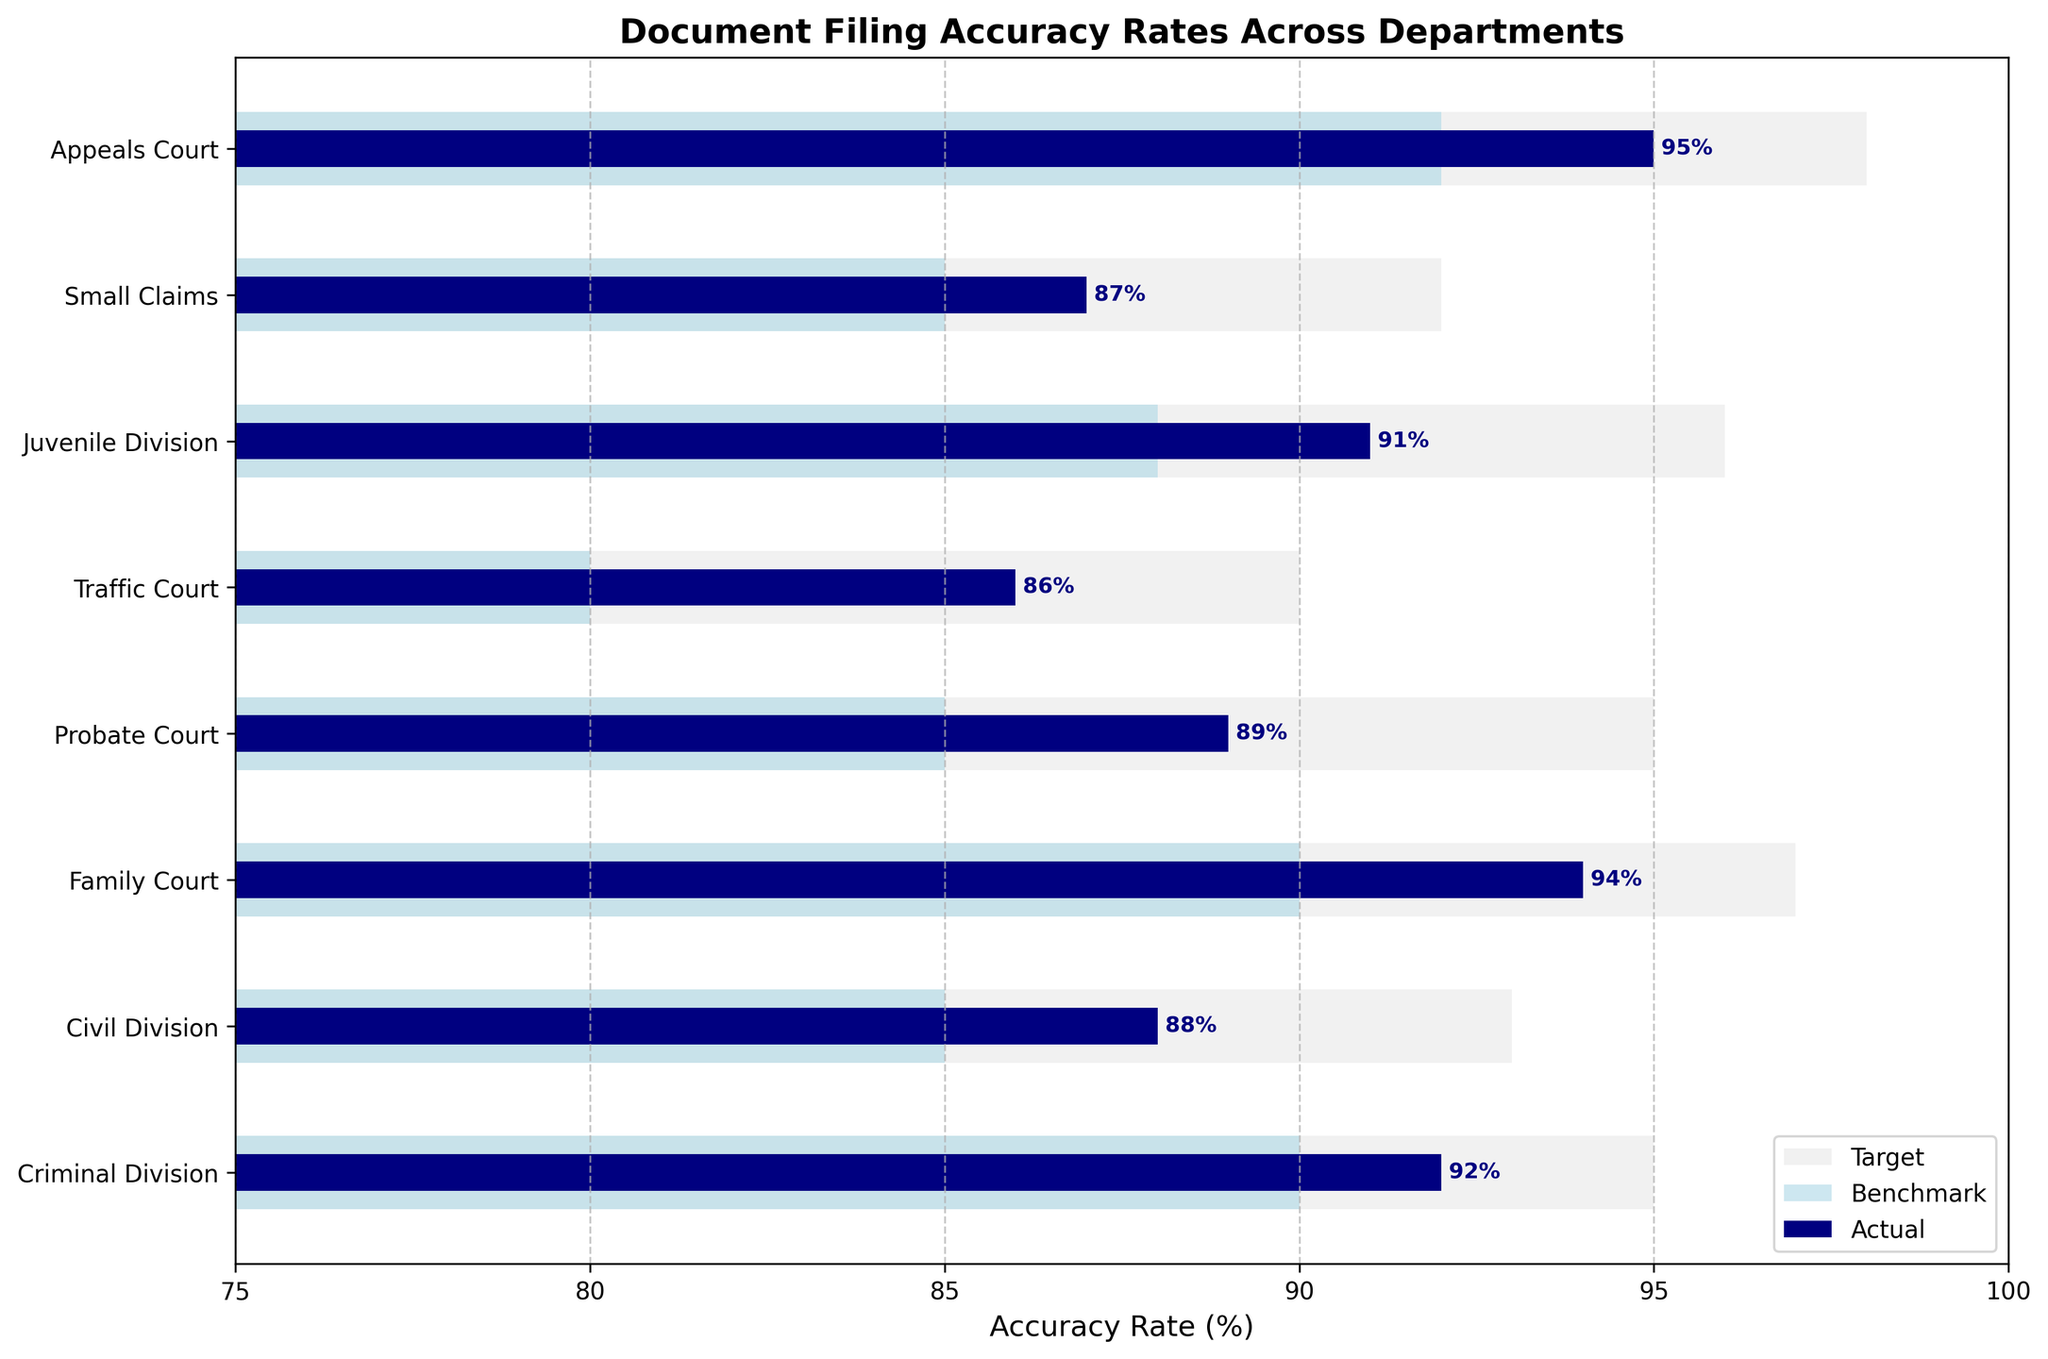what is the title of the figure? The title of a figure is typically displayed at the top and summarizes the main point of the visualization. In this case, the title "Document Filing Accuracy Rates Across Departments" is mentioned in the code provided.
Answer: Document Filing Accuracy Rates Across Departments which department has the highest actual accuracy rate? By examining the actual accuracy rates represented by the shortest dark navy bars on the plot, the department with the highest value is 95%, which corresponds to the Appeals Court.
Answer: Appeals Court what is the benchmark accuracy rate for the Civil Division? The benchmark accuracy rate is represented by light blue bars in the plot. For the Civil Division, this value is 85%.
Answer: 85% what's the difference between the actual and target accuracy rates for the Small Claims department? The actual accuracy rate is represented by the darkest bar, and the target rate is shown by the lightest bar. For the Small Claims department, the actual rate is 87% and the target rate is 92%. The difference is 92 - 87 = 5%.
Answer: 5% how many departments have a benchmark accuracy rate of 90% or higher? By inspecting the light blue bars corresponding to benchmark accuracy rates, we find that the departments with a benchmark rate of 90% or higher are Criminal Division (90%), Family Court (90%), Juvenile Division (88%), and Appeals Court (92%). There are 3 departments in total.
Answer: 3 which department has the smallest difference between benchmark and actual accuracy rates? This requires identifying the difference between the light blue and dark navy bars for each department and finding the smallest difference. The Criminal Division has values of 90 (benchmark) and 92 (actual), resulting in a difference of 2, which is the smallest among the departments.
Answer: Criminal Division in which departments is the actual accuracy rate below the benchmark? To find these departments, we compare the actual accuracy rates (dark navy bars) to the benchmark rates (light blue bars). The only departments where the actual rate is below the benchmark rate are Juvenile Division and Traffic Court.
Answer: Juvenile Division, Traffic Court what's the average target accuracy rate across all departments? To find the average target accuracy rate, sum up all the target rates and divide by the number of departments. The target rates are 95, 93, 97, 95, 90, 96, 92, 98. The sum is 746, and there are 8 departments. The average is 746 / 8 = 93.25%.
Answer: 93.25 which department exceeded its target accuracy rate, and by how much? The Appeals Court has an actual accuracy rate of 95%, while its target was 92%. So, it exceeded its target by 95 - 92 = 3%.
Answer: Appeals Court, 3 which department shows the largest gap between target and benchmark accuracy rates? This requires identifying the difference between the lightest (target) and light blue (benchmark) bars for each department. The Family Court has a target of 97% and a benchmark of 90%, leading to a difference of 7%.
Answer: Family Court 